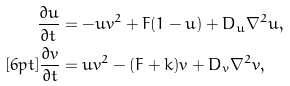<formula> <loc_0><loc_0><loc_500><loc_500>\frac { \partial u } { \partial t } & = - u v ^ { 2 } + F ( 1 - u ) + D _ { u } \nabla ^ { 2 } u , \\ [ 6 p t ] \frac { \partial v } { \partial t } & = u v ^ { 2 } - ( F + k ) v + D _ { v } \nabla ^ { 2 } v ,</formula> 